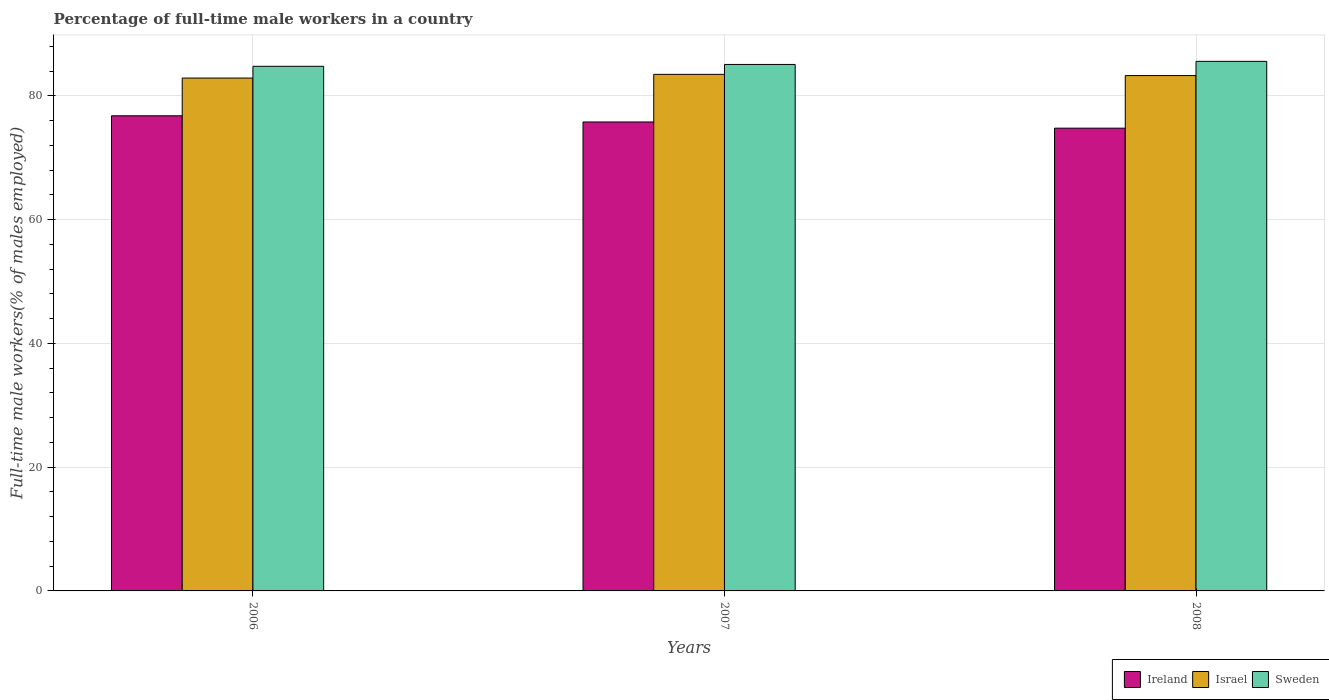Are the number of bars per tick equal to the number of legend labels?
Provide a short and direct response. Yes. How many bars are there on the 2nd tick from the left?
Your response must be concise. 3. What is the label of the 3rd group of bars from the left?
Your answer should be very brief. 2008. In how many cases, is the number of bars for a given year not equal to the number of legend labels?
Your answer should be compact. 0. What is the percentage of full-time male workers in Ireland in 2007?
Provide a succinct answer. 75.8. Across all years, what is the maximum percentage of full-time male workers in Sweden?
Provide a succinct answer. 85.6. Across all years, what is the minimum percentage of full-time male workers in Ireland?
Keep it short and to the point. 74.8. What is the total percentage of full-time male workers in Ireland in the graph?
Offer a very short reply. 227.4. What is the difference between the percentage of full-time male workers in Ireland in 2006 and that in 2008?
Make the answer very short. 2. What is the difference between the percentage of full-time male workers in Sweden in 2008 and the percentage of full-time male workers in Israel in 2006?
Offer a terse response. 2.7. What is the average percentage of full-time male workers in Sweden per year?
Give a very brief answer. 85.17. In the year 2007, what is the difference between the percentage of full-time male workers in Sweden and percentage of full-time male workers in Israel?
Your answer should be very brief. 1.6. What is the ratio of the percentage of full-time male workers in Ireland in 2006 to that in 2007?
Your answer should be compact. 1.01. Is the percentage of full-time male workers in Israel in 2006 less than that in 2007?
Provide a succinct answer. Yes. Is the difference between the percentage of full-time male workers in Sweden in 2007 and 2008 greater than the difference between the percentage of full-time male workers in Israel in 2007 and 2008?
Offer a very short reply. No. What is the difference between the highest and the second highest percentage of full-time male workers in Israel?
Offer a very short reply. 0.2. What is the difference between the highest and the lowest percentage of full-time male workers in Sweden?
Your answer should be very brief. 0.8. In how many years, is the percentage of full-time male workers in Ireland greater than the average percentage of full-time male workers in Ireland taken over all years?
Your answer should be compact. 1. What does the 2nd bar from the left in 2008 represents?
Keep it short and to the point. Israel. What does the 3rd bar from the right in 2007 represents?
Offer a very short reply. Ireland. How many bars are there?
Offer a terse response. 9. Are all the bars in the graph horizontal?
Ensure brevity in your answer.  No. How many years are there in the graph?
Ensure brevity in your answer.  3. What is the difference between two consecutive major ticks on the Y-axis?
Your answer should be compact. 20. Does the graph contain any zero values?
Make the answer very short. No. How are the legend labels stacked?
Offer a very short reply. Horizontal. What is the title of the graph?
Your response must be concise. Percentage of full-time male workers in a country. Does "Oman" appear as one of the legend labels in the graph?
Provide a short and direct response. No. What is the label or title of the Y-axis?
Ensure brevity in your answer.  Full-time male workers(% of males employed). What is the Full-time male workers(% of males employed) of Ireland in 2006?
Offer a terse response. 76.8. What is the Full-time male workers(% of males employed) in Israel in 2006?
Keep it short and to the point. 82.9. What is the Full-time male workers(% of males employed) in Sweden in 2006?
Offer a terse response. 84.8. What is the Full-time male workers(% of males employed) in Ireland in 2007?
Provide a short and direct response. 75.8. What is the Full-time male workers(% of males employed) of Israel in 2007?
Provide a short and direct response. 83.5. What is the Full-time male workers(% of males employed) of Sweden in 2007?
Provide a succinct answer. 85.1. What is the Full-time male workers(% of males employed) in Ireland in 2008?
Provide a succinct answer. 74.8. What is the Full-time male workers(% of males employed) in Israel in 2008?
Your response must be concise. 83.3. What is the Full-time male workers(% of males employed) of Sweden in 2008?
Make the answer very short. 85.6. Across all years, what is the maximum Full-time male workers(% of males employed) of Ireland?
Ensure brevity in your answer.  76.8. Across all years, what is the maximum Full-time male workers(% of males employed) of Israel?
Your answer should be very brief. 83.5. Across all years, what is the maximum Full-time male workers(% of males employed) in Sweden?
Ensure brevity in your answer.  85.6. Across all years, what is the minimum Full-time male workers(% of males employed) in Ireland?
Your response must be concise. 74.8. Across all years, what is the minimum Full-time male workers(% of males employed) of Israel?
Provide a succinct answer. 82.9. Across all years, what is the minimum Full-time male workers(% of males employed) of Sweden?
Your response must be concise. 84.8. What is the total Full-time male workers(% of males employed) of Ireland in the graph?
Give a very brief answer. 227.4. What is the total Full-time male workers(% of males employed) of Israel in the graph?
Offer a very short reply. 249.7. What is the total Full-time male workers(% of males employed) of Sweden in the graph?
Your response must be concise. 255.5. What is the difference between the Full-time male workers(% of males employed) in Israel in 2006 and that in 2007?
Your answer should be very brief. -0.6. What is the difference between the Full-time male workers(% of males employed) in Sweden in 2006 and that in 2007?
Your response must be concise. -0.3. What is the difference between the Full-time male workers(% of males employed) of Ireland in 2006 and that in 2008?
Give a very brief answer. 2. What is the difference between the Full-time male workers(% of males employed) of Israel in 2006 and that in 2008?
Ensure brevity in your answer.  -0.4. What is the difference between the Full-time male workers(% of males employed) in Ireland in 2007 and that in 2008?
Your answer should be compact. 1. What is the difference between the Full-time male workers(% of males employed) in Israel in 2007 and that in 2008?
Make the answer very short. 0.2. What is the difference between the Full-time male workers(% of males employed) of Israel in 2006 and the Full-time male workers(% of males employed) of Sweden in 2007?
Give a very brief answer. -2.2. What is the difference between the Full-time male workers(% of males employed) of Ireland in 2006 and the Full-time male workers(% of males employed) of Israel in 2008?
Ensure brevity in your answer.  -6.5. What is the difference between the Full-time male workers(% of males employed) of Ireland in 2006 and the Full-time male workers(% of males employed) of Sweden in 2008?
Keep it short and to the point. -8.8. What is the average Full-time male workers(% of males employed) of Ireland per year?
Make the answer very short. 75.8. What is the average Full-time male workers(% of males employed) in Israel per year?
Provide a succinct answer. 83.23. What is the average Full-time male workers(% of males employed) of Sweden per year?
Provide a succinct answer. 85.17. In the year 2007, what is the difference between the Full-time male workers(% of males employed) of Ireland and Full-time male workers(% of males employed) of Israel?
Offer a very short reply. -7.7. In the year 2007, what is the difference between the Full-time male workers(% of males employed) in Ireland and Full-time male workers(% of males employed) in Sweden?
Provide a short and direct response. -9.3. In the year 2008, what is the difference between the Full-time male workers(% of males employed) of Israel and Full-time male workers(% of males employed) of Sweden?
Offer a terse response. -2.3. What is the ratio of the Full-time male workers(% of males employed) in Ireland in 2006 to that in 2007?
Offer a very short reply. 1.01. What is the ratio of the Full-time male workers(% of males employed) of Israel in 2006 to that in 2007?
Give a very brief answer. 0.99. What is the ratio of the Full-time male workers(% of males employed) of Sweden in 2006 to that in 2007?
Provide a short and direct response. 1. What is the ratio of the Full-time male workers(% of males employed) of Ireland in 2006 to that in 2008?
Make the answer very short. 1.03. What is the ratio of the Full-time male workers(% of males employed) in Ireland in 2007 to that in 2008?
Ensure brevity in your answer.  1.01. What is the ratio of the Full-time male workers(% of males employed) of Israel in 2007 to that in 2008?
Ensure brevity in your answer.  1. What is the ratio of the Full-time male workers(% of males employed) in Sweden in 2007 to that in 2008?
Offer a very short reply. 0.99. What is the difference between the highest and the second highest Full-time male workers(% of males employed) in Ireland?
Ensure brevity in your answer.  1. What is the difference between the highest and the second highest Full-time male workers(% of males employed) in Israel?
Provide a short and direct response. 0.2. What is the difference between the highest and the second highest Full-time male workers(% of males employed) of Sweden?
Give a very brief answer. 0.5. What is the difference between the highest and the lowest Full-time male workers(% of males employed) of Ireland?
Ensure brevity in your answer.  2. What is the difference between the highest and the lowest Full-time male workers(% of males employed) of Sweden?
Your response must be concise. 0.8. 